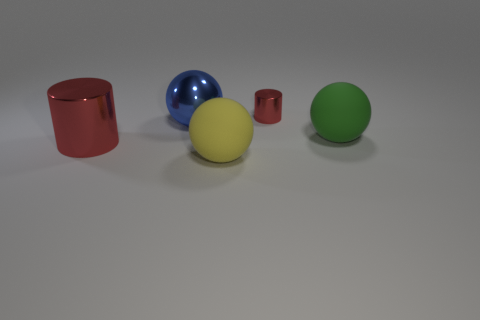Add 3 yellow matte objects. How many objects exist? 8 Subtract all cylinders. How many objects are left? 3 Add 2 big red metal things. How many big red metal things are left? 3 Add 5 blue metal things. How many blue metal things exist? 6 Subtract 1 red cylinders. How many objects are left? 4 Subtract all tiny green spheres. Subtract all small shiny cylinders. How many objects are left? 4 